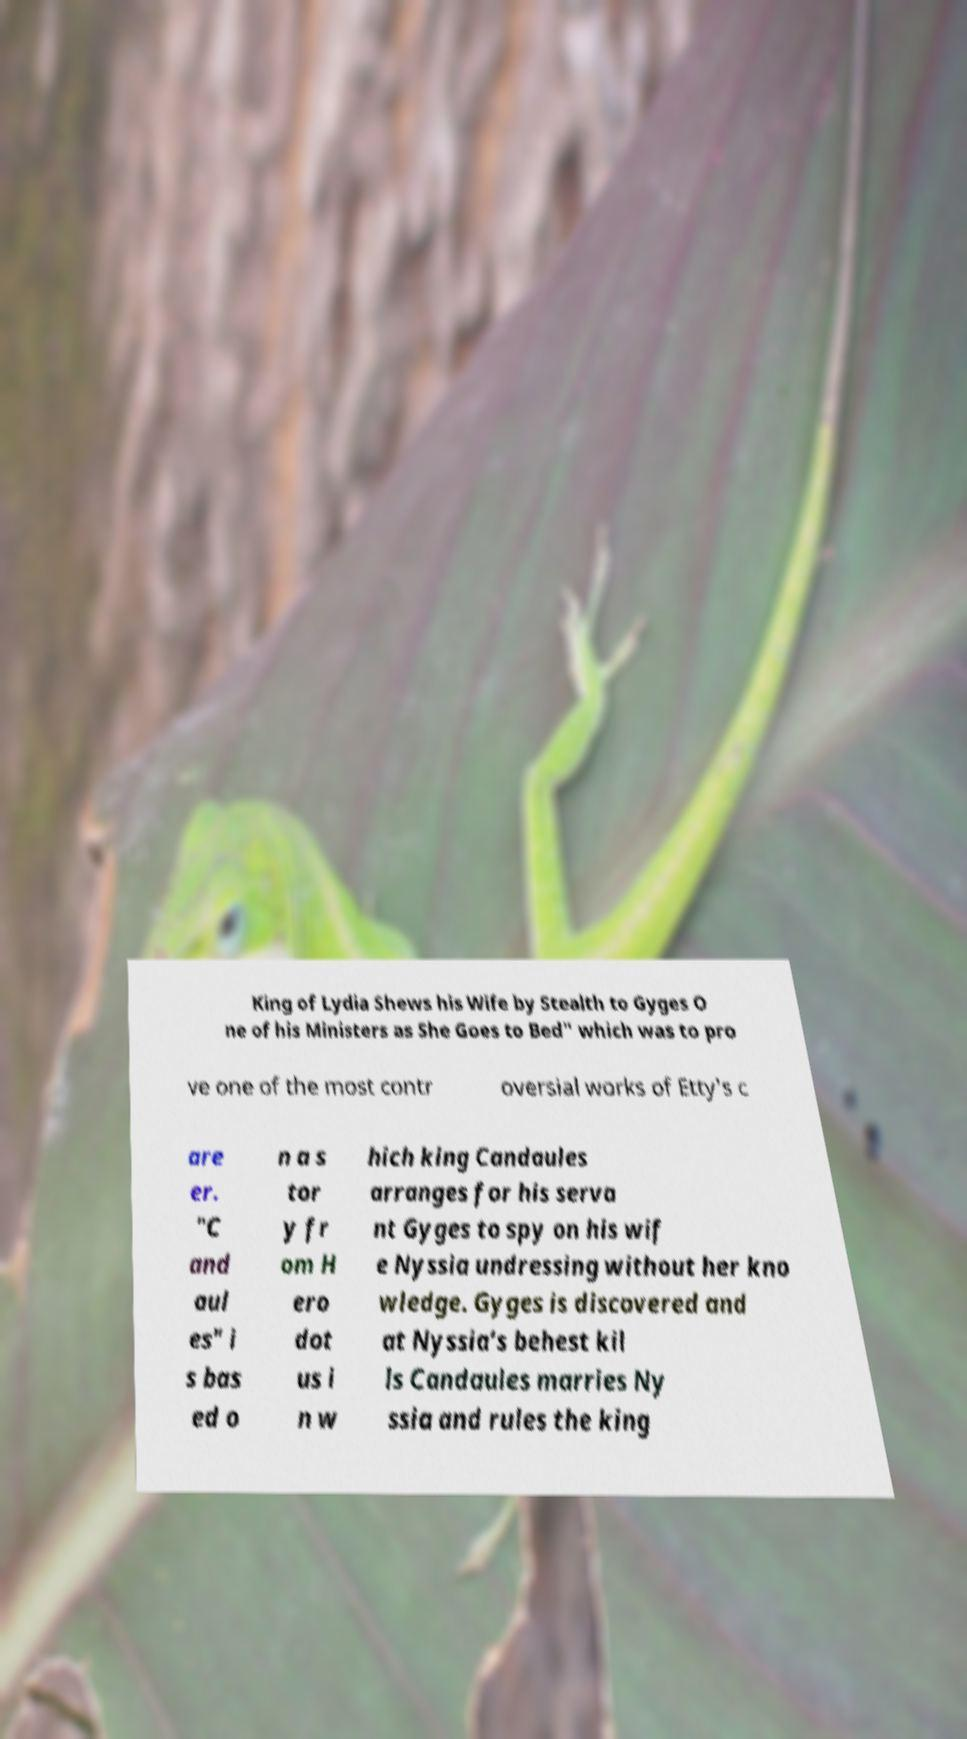Could you extract and type out the text from this image? King of Lydia Shews his Wife by Stealth to Gyges O ne of his Ministers as She Goes to Bed" which was to pro ve one of the most contr oversial works of Etty's c are er. "C and aul es" i s bas ed o n a s tor y fr om H ero dot us i n w hich king Candaules arranges for his serva nt Gyges to spy on his wif e Nyssia undressing without her kno wledge. Gyges is discovered and at Nyssia's behest kil ls Candaules marries Ny ssia and rules the king 